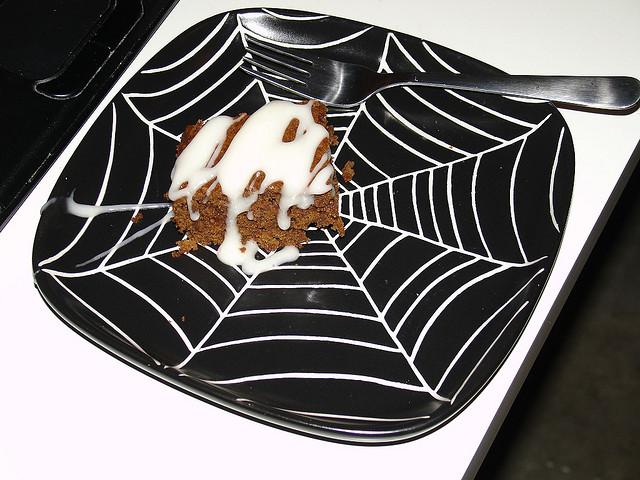Is this dessert?
Keep it brief. Yes. What does that design on the plate look like?
Be succinct. Spider web. What utensil is on the plate?
Concise answer only. Fork. 